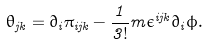<formula> <loc_0><loc_0><loc_500><loc_500>\theta _ { j k } = \partial _ { i } \pi _ { i j k } - \frac { 1 } { 3 ! } m \epsilon ^ { i j k } \partial _ { i } \phi .</formula> 